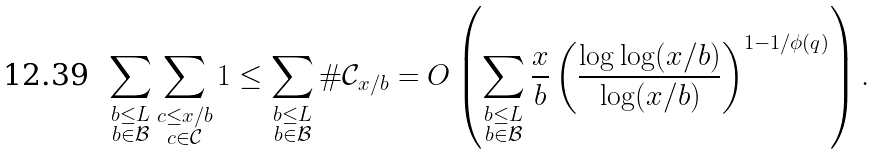Convert formula to latex. <formula><loc_0><loc_0><loc_500><loc_500>\sum _ { \substack { b \leq L \\ b \in \mathcal { B } } } \sum _ { \substack { c \leq x / b \\ c \in \mathcal { C } } } 1 \leq \sum _ { \substack { b \leq L \\ b \in \mathcal { B } } } \# \mathcal { C } _ { x / b } = O \left ( \sum _ { \substack { b \leq L \\ b \in \mathcal { B } } } \frac { x } { b } \left ( \frac { \log \log ( x / b ) } { \log ( x / b ) } \right ) ^ { 1 - 1 / \phi ( q ) } \right ) .</formula> 